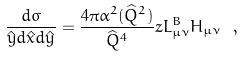<formula> <loc_0><loc_0><loc_500><loc_500>\frac { d \sigma } { \hat { y } d \hat { x } d \hat { y } } = \frac { 4 \pi \alpha ^ { 2 } ( \widehat { Q } ^ { 2 } ) } { \widehat { Q } ^ { 4 } } z L _ { \mu \nu } ^ { B } H _ { \mu \nu } \ ,</formula> 